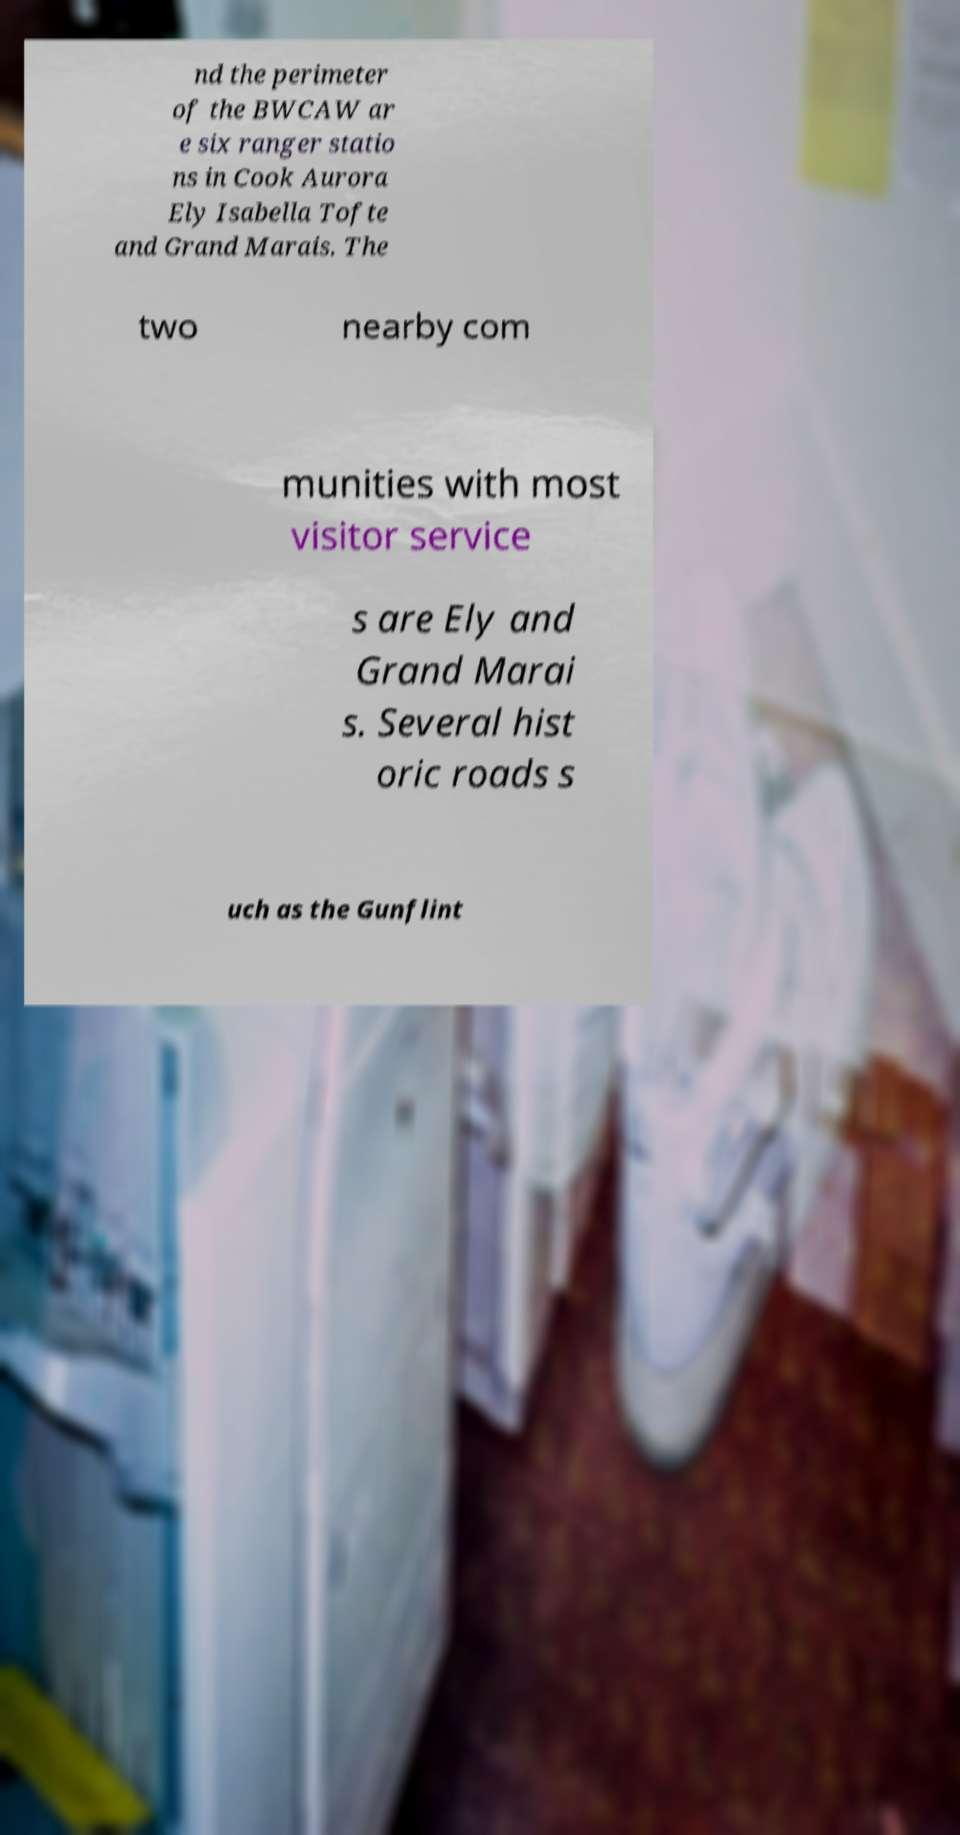There's text embedded in this image that I need extracted. Can you transcribe it verbatim? nd the perimeter of the BWCAW ar e six ranger statio ns in Cook Aurora Ely Isabella Tofte and Grand Marais. The two nearby com munities with most visitor service s are Ely and Grand Marai s. Several hist oric roads s uch as the Gunflint 